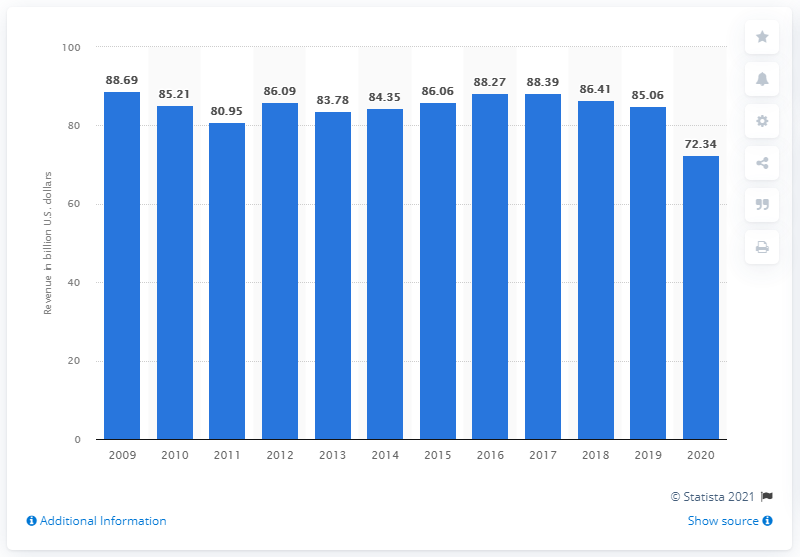Identify some key points in this picture. In 2020, the total revenue of Wells Fargo was 72.34 billion dollars. 